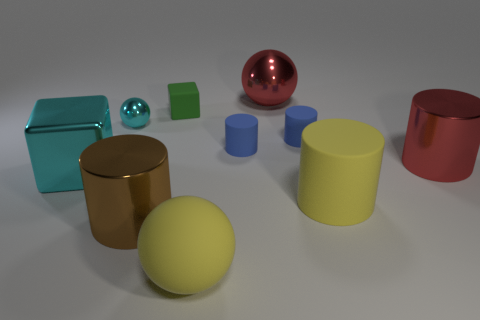Subtract 2 cylinders. How many cylinders are left? 3 Subtract all red cylinders. How many cylinders are left? 4 Subtract all big yellow cylinders. How many cylinders are left? 4 Subtract all gray cylinders. Subtract all cyan cubes. How many cylinders are left? 5 Subtract all spheres. How many objects are left? 7 Add 7 large cyan things. How many large cyan things exist? 8 Subtract 0 blue spheres. How many objects are left? 10 Subtract all cyan matte cubes. Subtract all tiny rubber blocks. How many objects are left? 9 Add 6 small green rubber blocks. How many small green rubber blocks are left? 7 